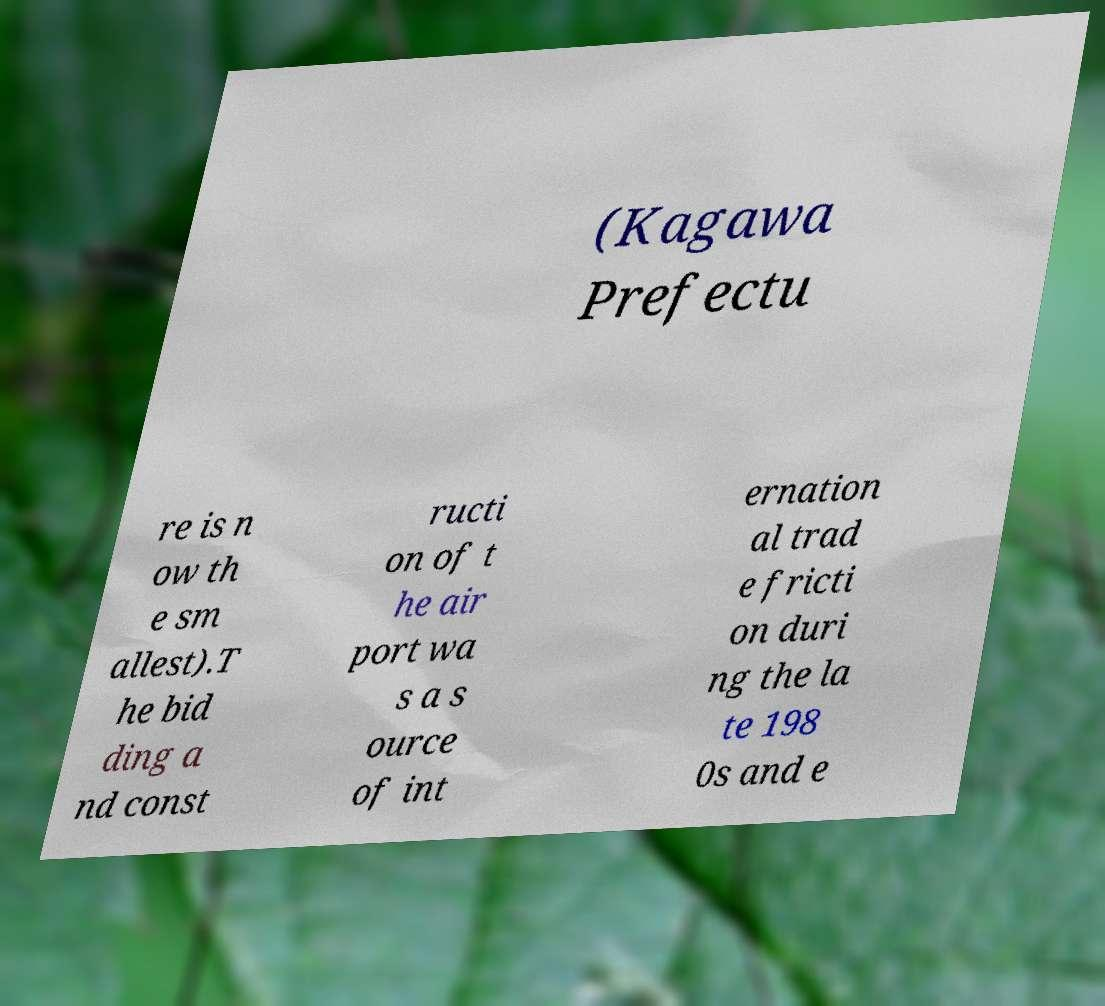Could you assist in decoding the text presented in this image and type it out clearly? (Kagawa Prefectu re is n ow th e sm allest).T he bid ding a nd const ructi on of t he air port wa s a s ource of int ernation al trad e fricti on duri ng the la te 198 0s and e 